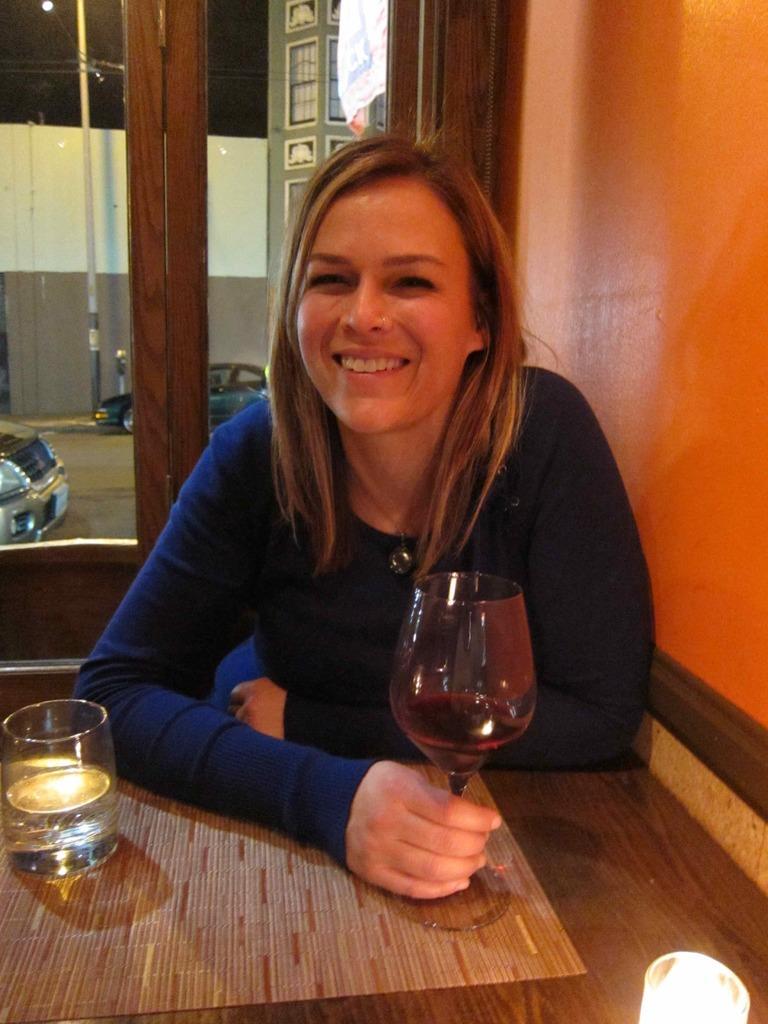How would you summarize this image in a sentence or two? This picture shows a woman seated on the chair and holding a wine glass in her hand and we see a glass on the table 